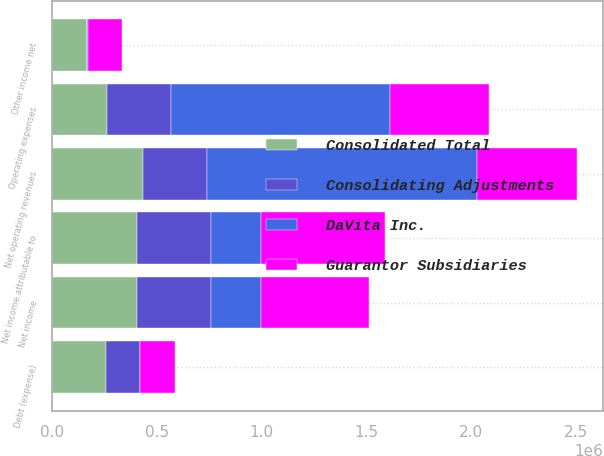Convert chart. <chart><loc_0><loc_0><loc_500><loc_500><stacked_bar_chart><ecel><fcel>Net operating revenues<fcel>Operating expenses<fcel>Debt (expense)<fcel>Other income net<fcel>Net income<fcel>Net income attributable to<nl><fcel>Consolidated Total<fcel>431780<fcel>259302<fcel>257243<fcel>165934<fcel>405683<fcel>405683<nl><fcel>Consolidating Adjustments<fcel>307210<fcel>307210<fcel>163034<fcel>1837<fcel>355119<fcel>355119<nl><fcel>DaVita Inc.<fcel>1.28952e+06<fcel>1.04499e+06<fcel>1277<fcel>1214<fcel>236865<fcel>236865<nl><fcel>Guarantor Subsidiaries<fcel>477438<fcel>477438<fcel>165565<fcel>165565<fcel>513448<fcel>591984<nl></chart> 